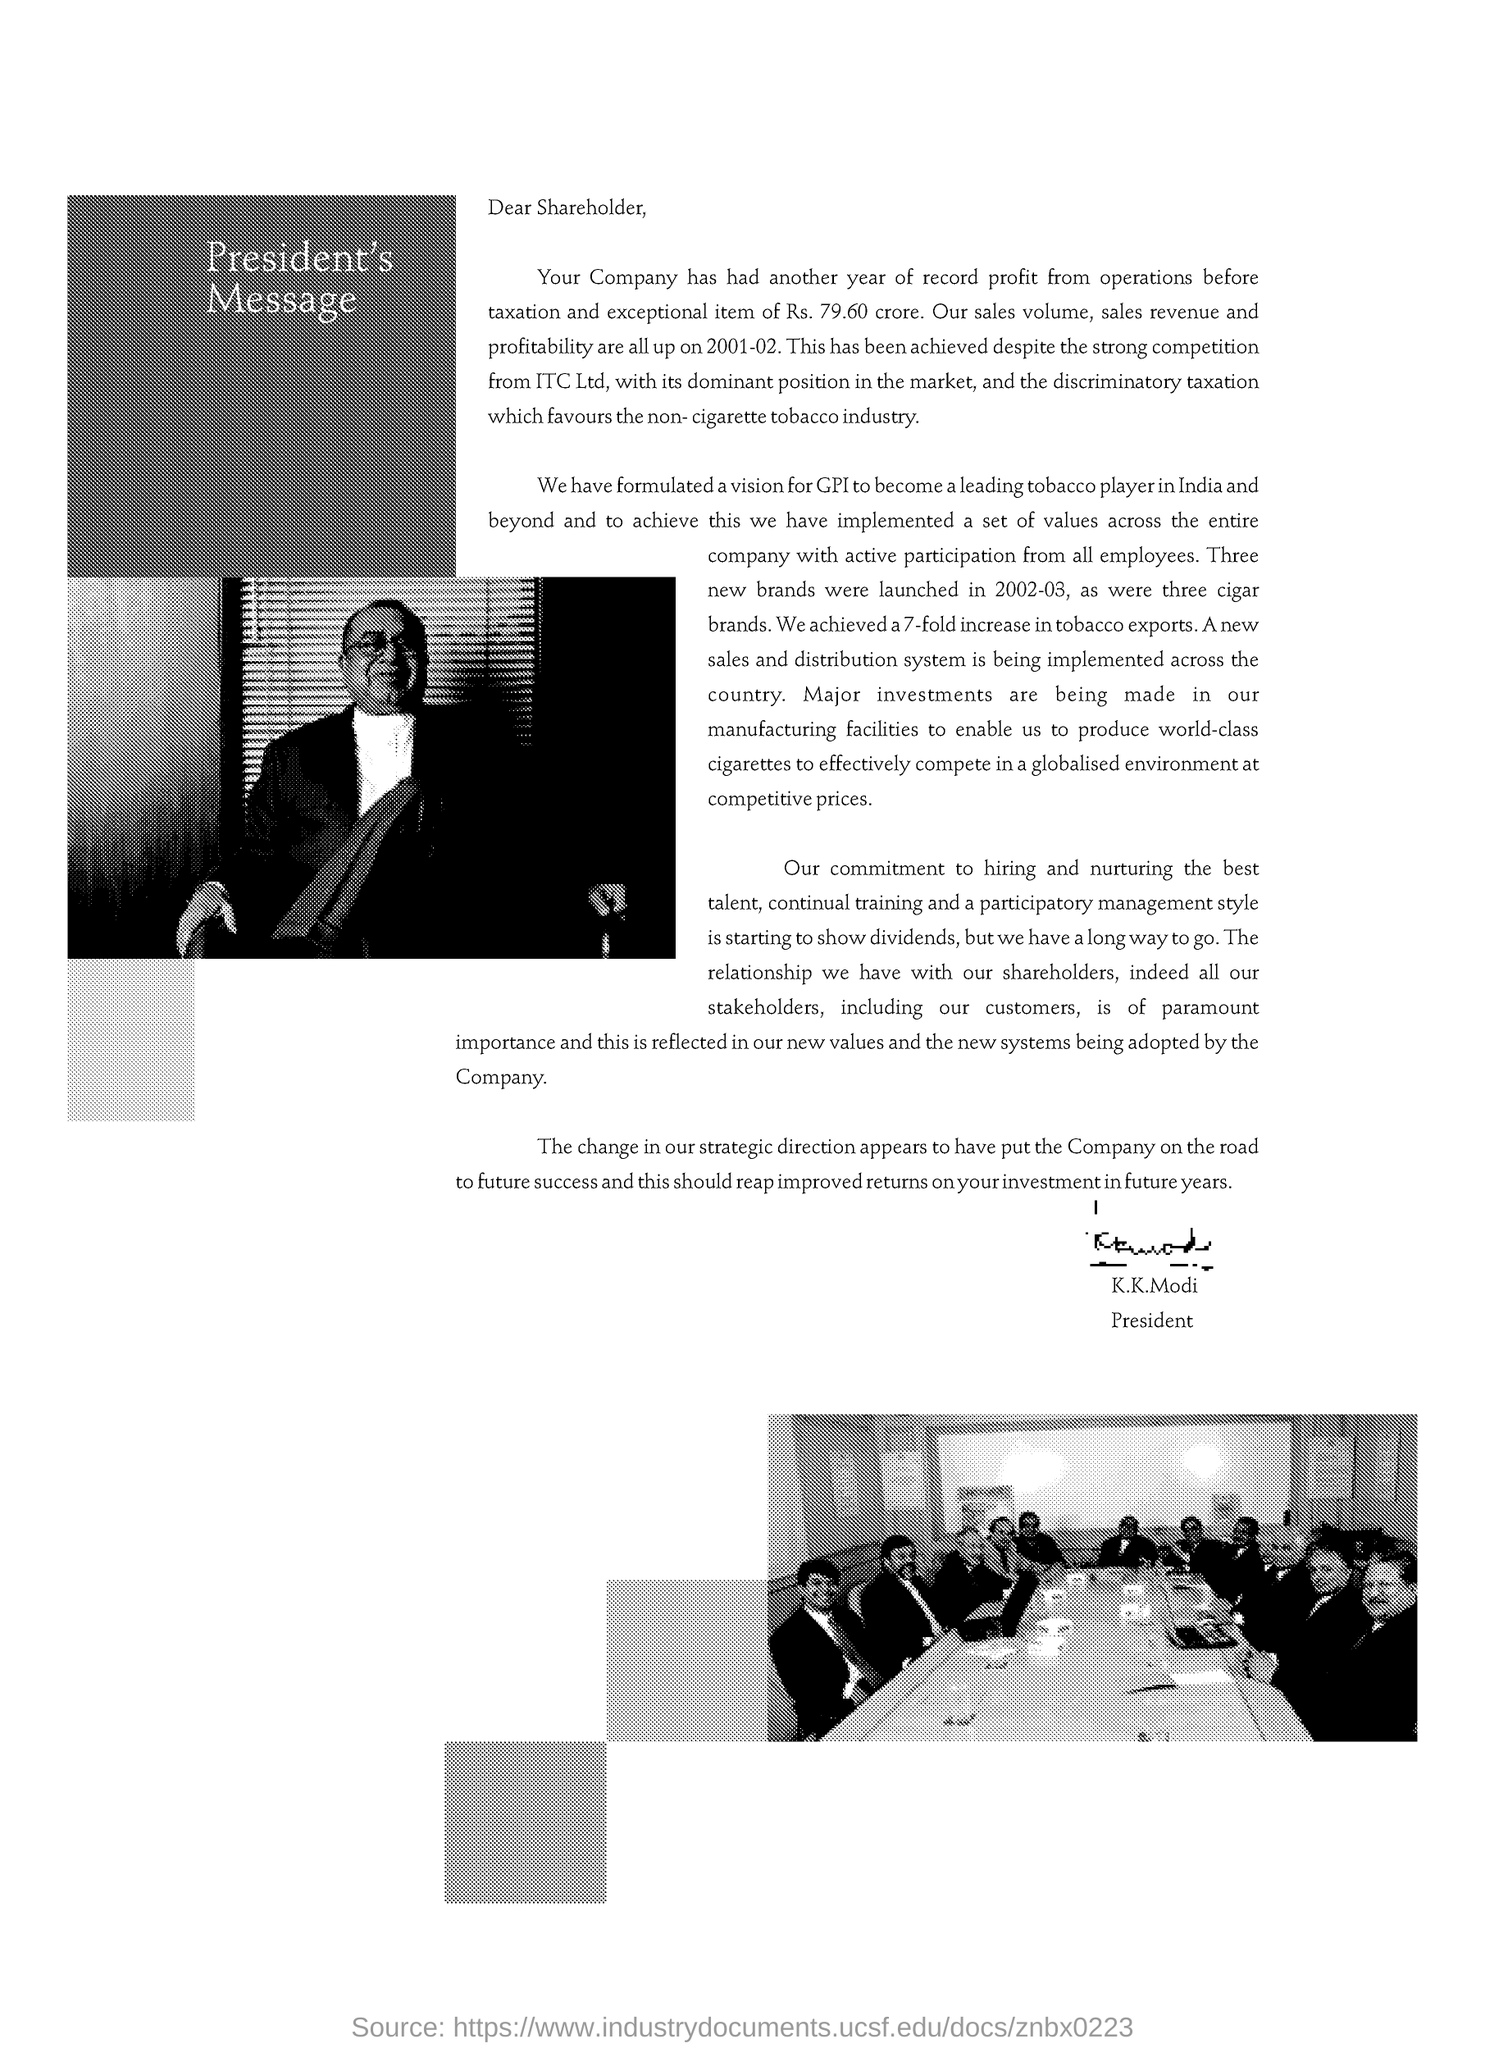The profit has been achieved despite the strong competition from which company ?
Ensure brevity in your answer.  ITC Ltd. 